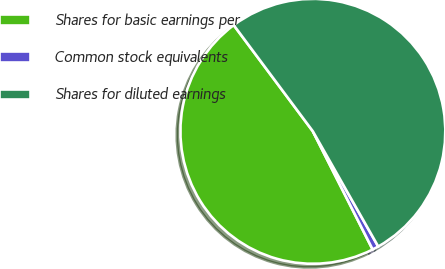Convert chart. <chart><loc_0><loc_0><loc_500><loc_500><pie_chart><fcel>Shares for basic earnings per<fcel>Common stock equivalents<fcel>Shares for diluted earnings<nl><fcel>47.26%<fcel>0.76%<fcel>51.98%<nl></chart> 